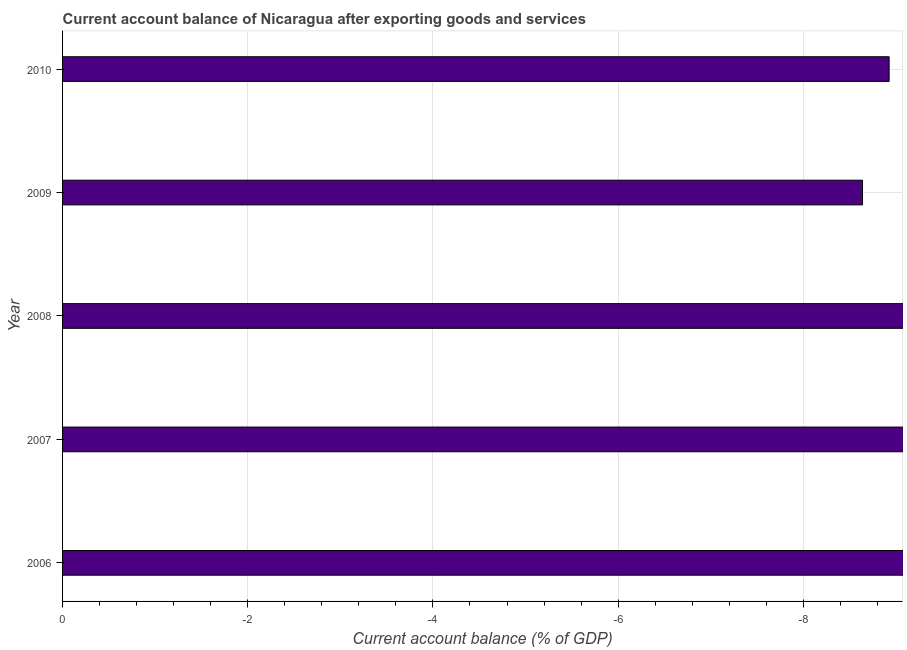Does the graph contain any zero values?
Your answer should be very brief. Yes. What is the title of the graph?
Provide a short and direct response. Current account balance of Nicaragua after exporting goods and services. What is the label or title of the X-axis?
Ensure brevity in your answer.  Current account balance (% of GDP). What is the current account balance in 2006?
Keep it short and to the point. 0. In how many years, is the current account balance greater than the average current account balance taken over all years?
Make the answer very short. 0. How many bars are there?
Provide a short and direct response. 0. Are all the bars in the graph horizontal?
Offer a terse response. Yes. How many years are there in the graph?
Keep it short and to the point. 5. What is the Current account balance (% of GDP) of 2008?
Keep it short and to the point. 0. What is the Current account balance (% of GDP) in 2009?
Offer a terse response. 0. 